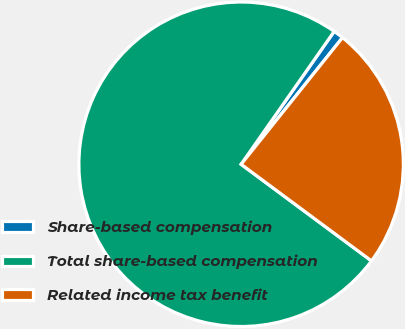<chart> <loc_0><loc_0><loc_500><loc_500><pie_chart><fcel>Share-based compensation<fcel>Total share-based compensation<fcel>Related income tax benefit<nl><fcel>1.02%<fcel>74.58%<fcel>24.41%<nl></chart> 